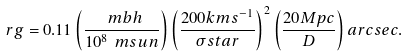Convert formula to latex. <formula><loc_0><loc_0><loc_500><loc_500>\ r g = 0 . 1 1 \left ( \frac { \ m b h } { 1 0 ^ { 8 } \ m s u n } \right ) \left ( \frac { 2 0 0 k m s ^ { - 1 } } { \sigma s t a r } \right ) ^ { 2 } \left ( \frac { 2 0 M p c } { D } \right ) a r c s e c .</formula> 